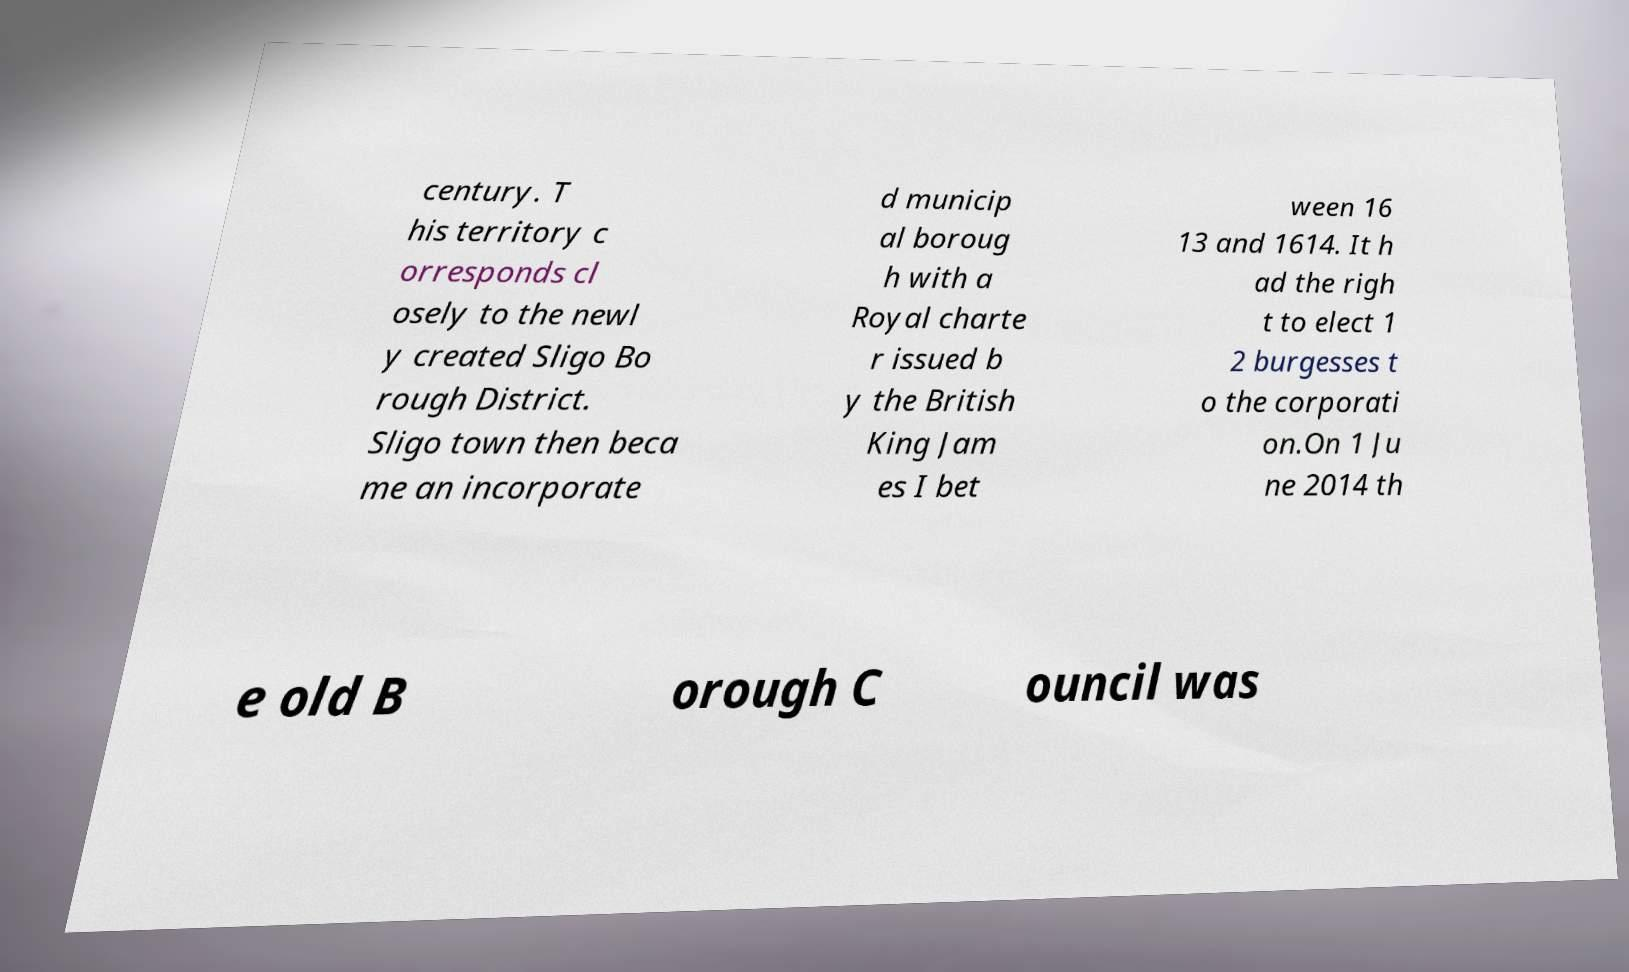For documentation purposes, I need the text within this image transcribed. Could you provide that? century. T his territory c orresponds cl osely to the newl y created Sligo Bo rough District. Sligo town then beca me an incorporate d municip al boroug h with a Royal charte r issued b y the British King Jam es I bet ween 16 13 and 1614. It h ad the righ t to elect 1 2 burgesses t o the corporati on.On 1 Ju ne 2014 th e old B orough C ouncil was 